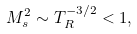Convert formula to latex. <formula><loc_0><loc_0><loc_500><loc_500>M _ { s } ^ { 2 } \sim T _ { R } ^ { - 3 / 2 } < 1 ,</formula> 